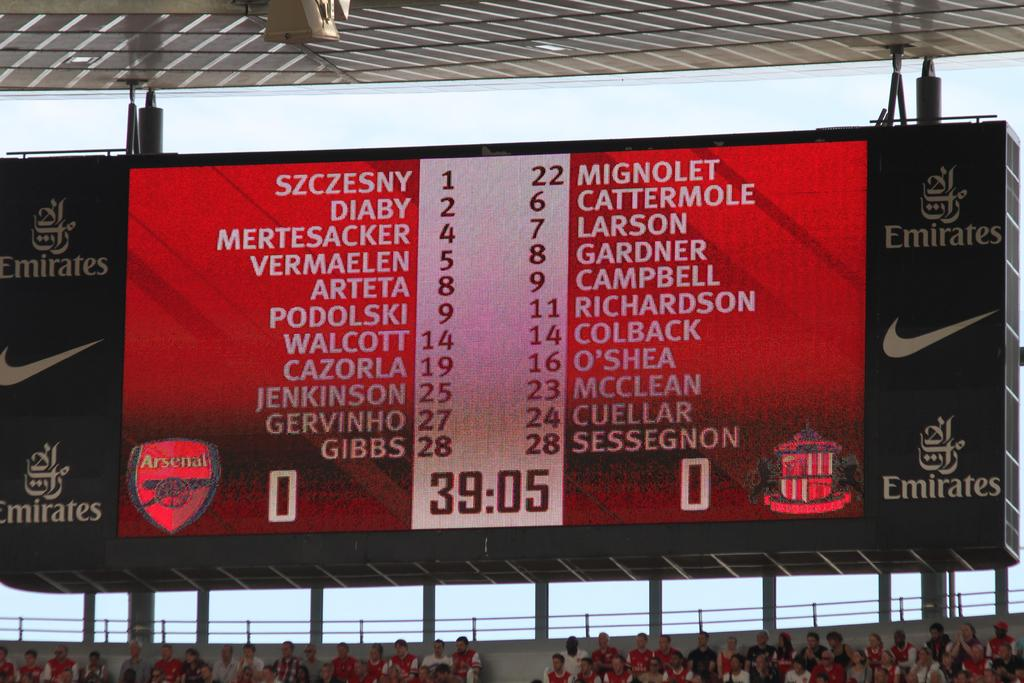What is the main object in the foreground of the image? There is a screen in the foreground of the image. How far does the screen extend in the image? The screen extends to the ceiling in the image. What can be seen in the bottom part of the image? There is a crowd sitting in the bottom part of the image, and a railing is present. What is visible in the background of the image? The sky is visible in the background of the image. What type of belief is being discussed by the crowd in the image? There is no indication in the image of a specific belief being discussed by the crowd. What key is used to unlock the screen in the image? There is no key present in the image, and the screen does not require a key to unlock. 